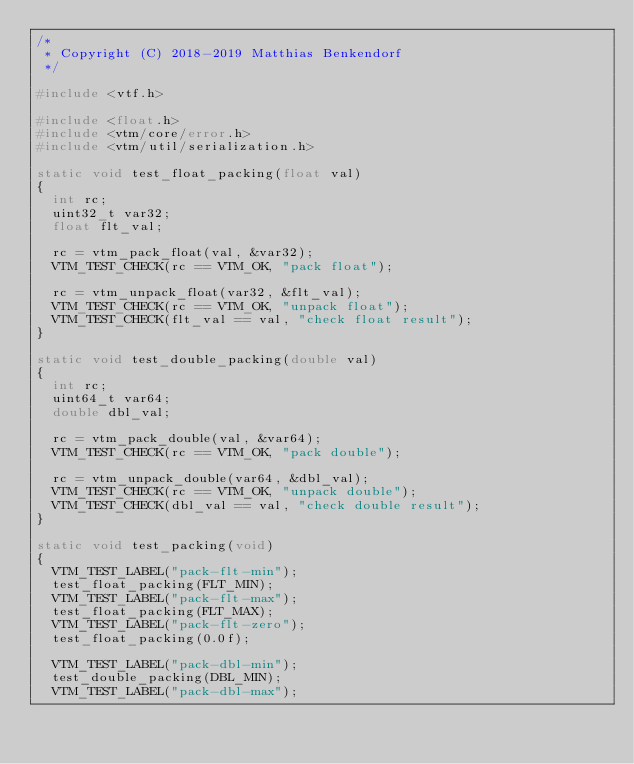<code> <loc_0><loc_0><loc_500><loc_500><_C_>/*
 * Copyright (C) 2018-2019 Matthias Benkendorf
 */

#include <vtf.h>

#include <float.h>
#include <vtm/core/error.h>
#include <vtm/util/serialization.h>

static void test_float_packing(float val)
{
	int rc;
	uint32_t var32;
	float flt_val;

	rc = vtm_pack_float(val, &var32);
	VTM_TEST_CHECK(rc == VTM_OK, "pack float");

	rc = vtm_unpack_float(var32, &flt_val);
	VTM_TEST_CHECK(rc == VTM_OK, "unpack float");
	VTM_TEST_CHECK(flt_val == val, "check float result");
}

static void test_double_packing(double val)
{
	int rc;
	uint64_t var64;
	double dbl_val;

	rc = vtm_pack_double(val, &var64);
	VTM_TEST_CHECK(rc == VTM_OK, "pack double");

	rc = vtm_unpack_double(var64, &dbl_val);
	VTM_TEST_CHECK(rc == VTM_OK, "unpack double");
	VTM_TEST_CHECK(dbl_val == val, "check double result");
}

static void test_packing(void)
{
	VTM_TEST_LABEL("pack-flt-min");
	test_float_packing(FLT_MIN);
	VTM_TEST_LABEL("pack-flt-max");
	test_float_packing(FLT_MAX);
	VTM_TEST_LABEL("pack-flt-zero");
	test_float_packing(0.0f);

	VTM_TEST_LABEL("pack-dbl-min");
	test_double_packing(DBL_MIN);
	VTM_TEST_LABEL("pack-dbl-max");</code> 